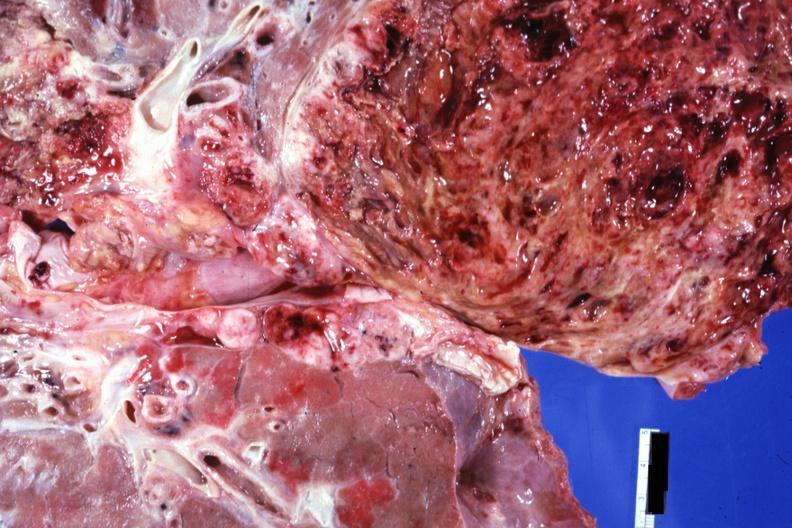where is this?
Answer the question using a single word or phrase. Thorax 